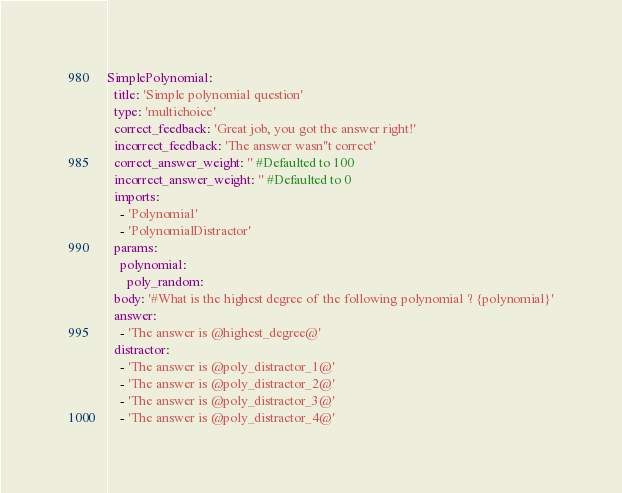<code> <loc_0><loc_0><loc_500><loc_500><_YAML_>SimplePolynomial:
  title: 'Simple polynomial question'
  type: 'multichoice'
  correct_feedback: 'Great job, you got the answer right!'
  incorrect_feedback: 'The answer wasn''t correct'
  correct_answer_weight: '' #Defaulted to 100
  incorrect_answer_weight: '' #Defaulted to 0
  imports:
    - 'Polynomial'
    - 'PolynomialDistractor'
  params:
    polynomial:
      poly_random:
  body: '#What is the highest degree of the following polynomial ? {polynomial}'
  answer:
    - 'The answer is @highest_degree@'
  distractor:
    - 'The answer is @poly_distractor_1@'
    - 'The answer is @poly_distractor_2@'
    - 'The answer is @poly_distractor_3@'
    - 'The answer is @poly_distractor_4@'</code> 